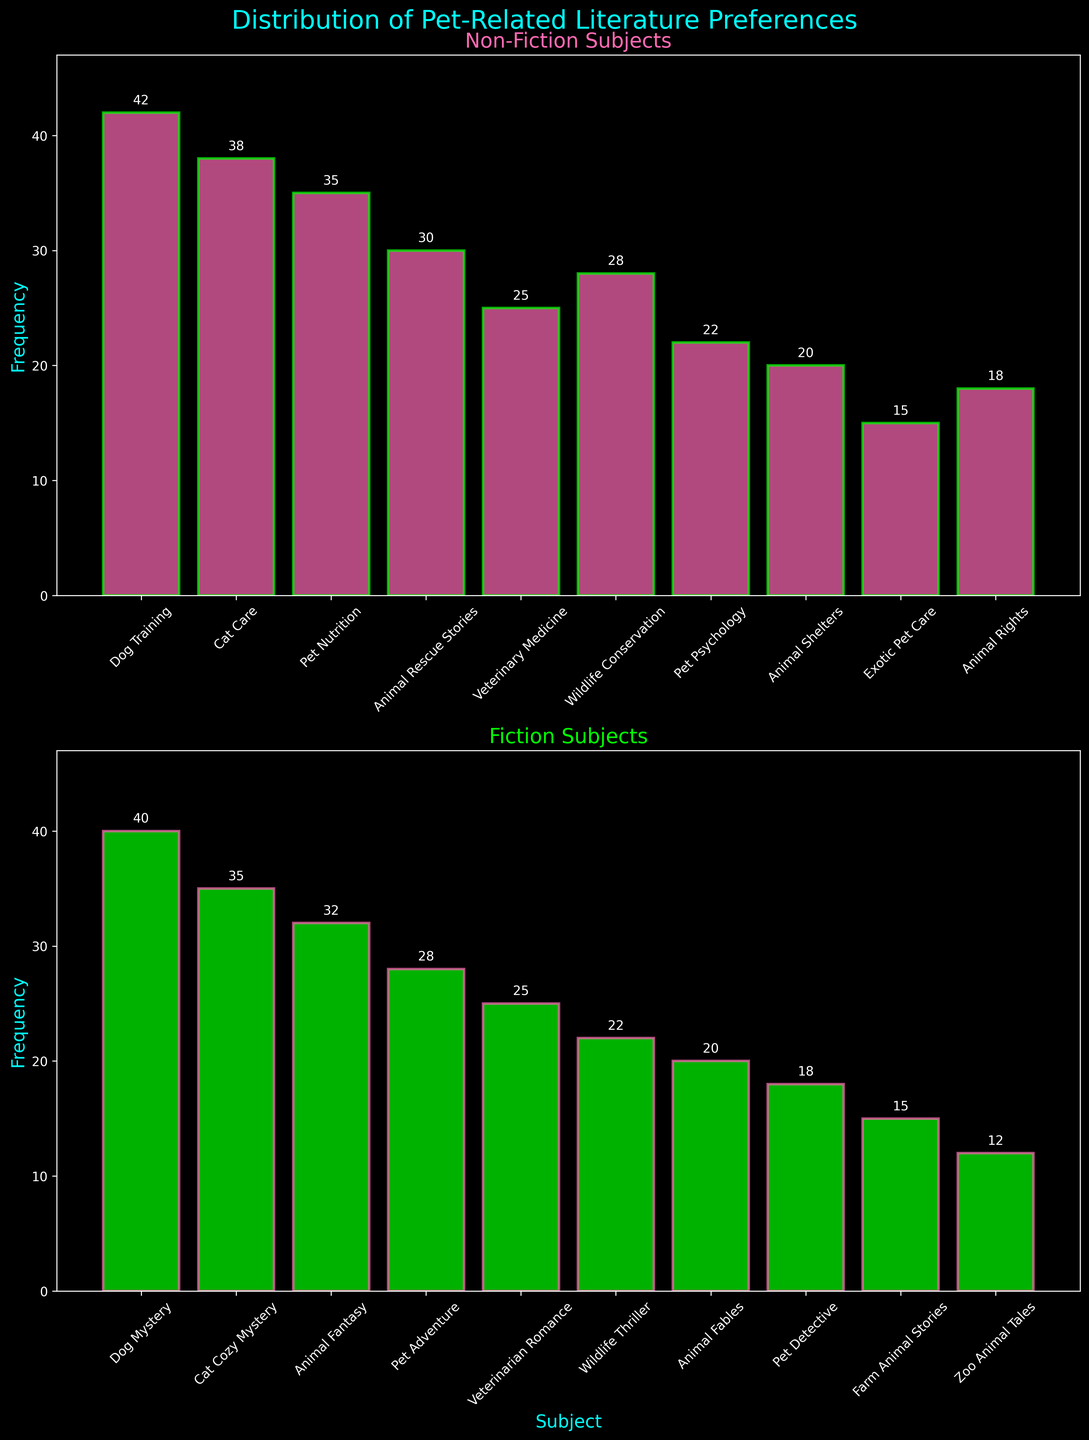Which category of subjects has the highest frequency? By inspecting the heights of the bars, we notice that "Dog Training" under the Non-fiction category has the highest frequency at 42.
Answer: Dog Training What is the frequency difference between "Pet Detective" and "Animal Rescue Stories"? "Pet Detective" has a frequency of 18, and "Animal Rescue Stories" has a frequency of 30. The difference is 30 - 18.
Answer: 12 Which fiction subject has the lowest frequency? By inspecting the Fiction subplot, "Zoo Animal Tales" has the lowest frequency with a value of 12.
Answer: Zoo Animal Tales Is the frequency of "Dog Mystery" greater than "Cat Cozy Mystery"? By comparing the two bars, "Dog Mystery" has a frequency of 40, whereas "Cat Cozy Mystery" has a frequency of 35. Thus, 40 is greater than 35.
Answer: Yes How many Non-fiction subjects have a frequency of at least 30? "Dog Training," "Cat Care," "Pet Nutrition," and "Animal Rescue Stories" are the non-fiction subjects with frequencies of 42, 38, 35, and 30, respectively. So, 4 subjects meet this criterion.
Answer: 4 What's the total frequency of all Fiction subjects? Summing up the frequencies of all the fiction subjects: 40 + 35 + 32 + 28 + 25 + 22 + 20 + 18 + 15 + 12. The total is 247.
Answer: 247 What's the average frequency of Non-fiction subjects? Sum the frequencies of all non-fiction subjects: 42 + 38 + 35 + 30 + 25 + 28 + 22 + 20 + 15 + 18 = 273. There are 10 subjects, so the average is 273/10.
Answer: 27.3 Which Non-fiction subject has the second lowest frequency? The Non-fiction subjects listed lowest to highest are: "Exotic Pet Care" (15), "Animal Shelters" (20), and "Pet Psychology" (22). Thus, "Animal Shelters" is the second lowest.
Answer: Animal Shelters What is the frequency range of Fiction subjects? The Fiction subjects' frequencies range from the lowest "Zoo Animal Tales" (12) to the highest "Dog Mystery" (40). The range is 40 - 12.
Answer: 28 Is the frequency of "Exotic Pet Care" less than half of "Dog Training"? The frequency of "Exotic Pet Care" is 15, and "Dog Training" is 42. Half of 42 is 21, and since 15 is less than 21, the answer is yes.
Answer: Yes 